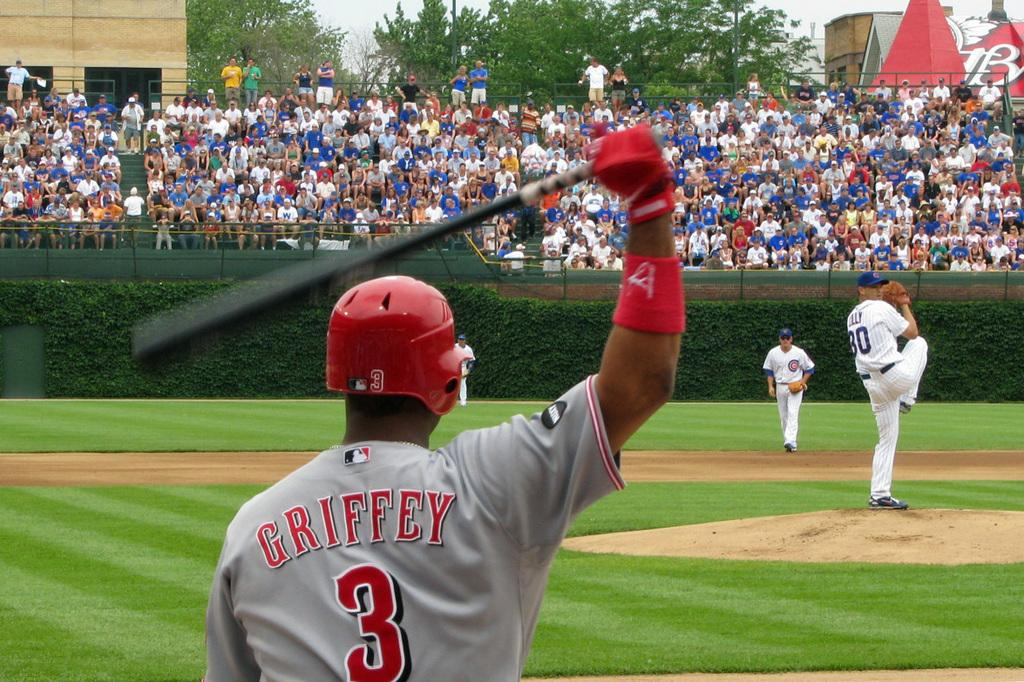<image>
Summarize the visual content of the image. Baseball player number 3 named Griffey has a bat in his hand, and he is on a field. 